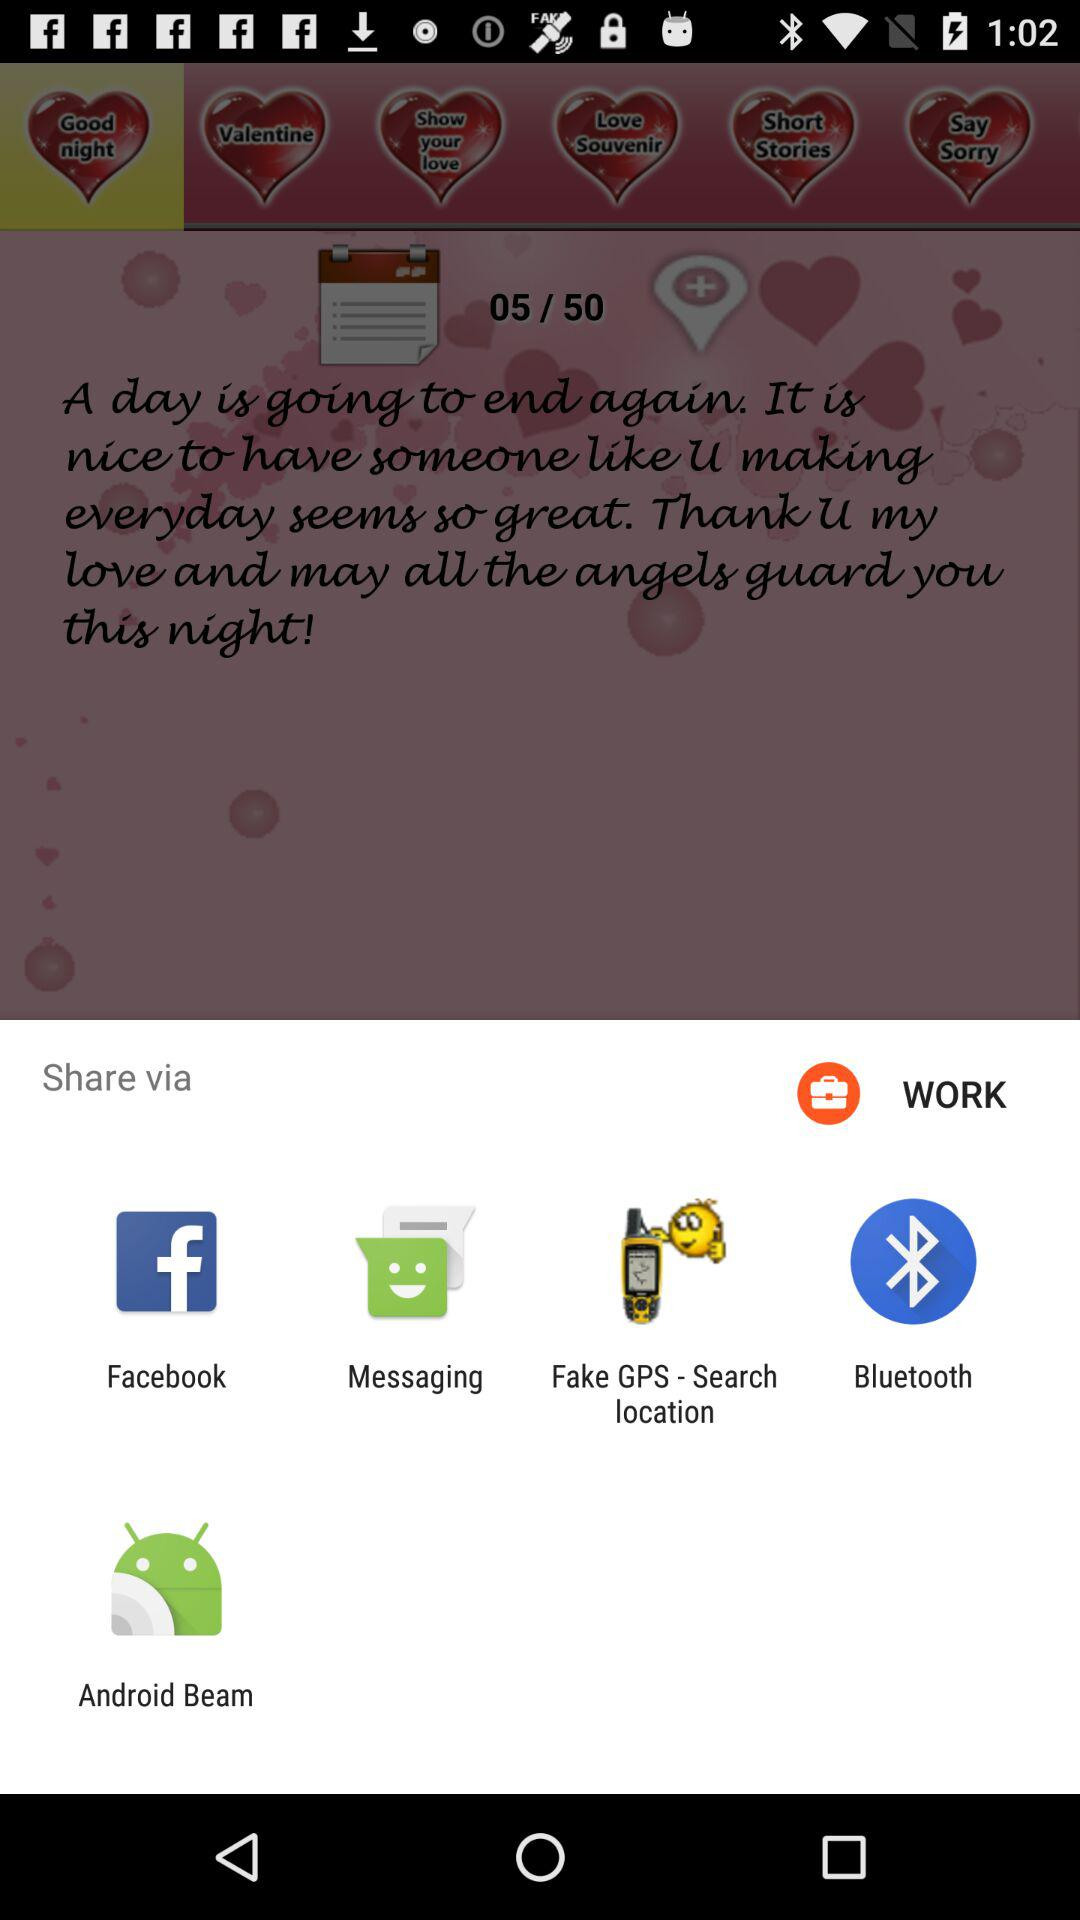What is the version of this application?
When the provided information is insufficient, respond with <no answer>. <no answer> 